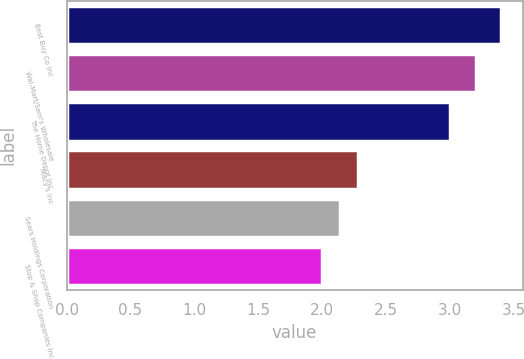<chart> <loc_0><loc_0><loc_500><loc_500><bar_chart><fcel>Best Buy Co Inc<fcel>Wal-Mart/Sam's Wholesale<fcel>The Home Depot Inc<fcel>Macy's Inc<fcel>Sears Holdings Corporation<fcel>Stop & Shop Companies Inc<nl><fcel>3.4<fcel>3.2<fcel>3<fcel>2.28<fcel>2.14<fcel>2<nl></chart> 